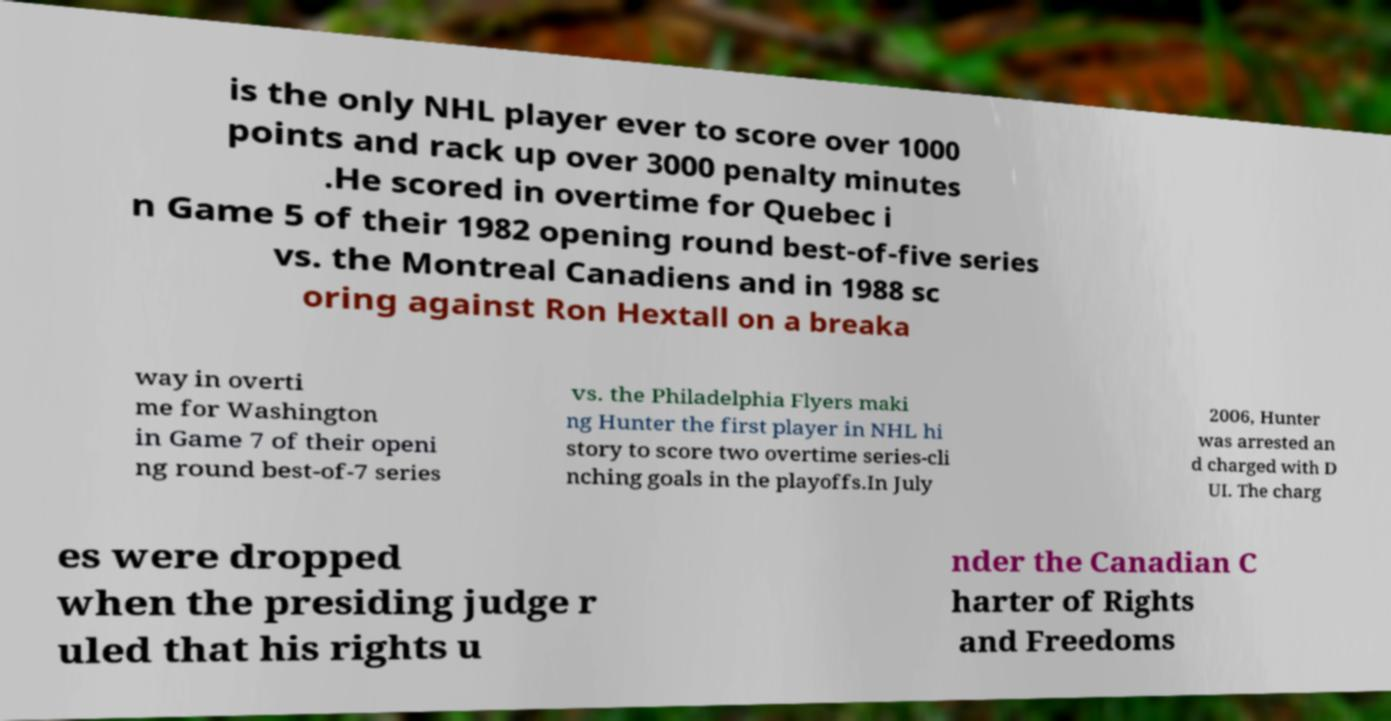Please read and relay the text visible in this image. What does it say? is the only NHL player ever to score over 1000 points and rack up over 3000 penalty minutes .He scored in overtime for Quebec i n Game 5 of their 1982 opening round best-of-five series vs. the Montreal Canadiens and in 1988 sc oring against Ron Hextall on a breaka way in overti me for Washington in Game 7 of their openi ng round best-of-7 series vs. the Philadelphia Flyers maki ng Hunter the first player in NHL hi story to score two overtime series-cli nching goals in the playoffs.In July 2006, Hunter was arrested an d charged with D UI. The charg es were dropped when the presiding judge r uled that his rights u nder the Canadian C harter of Rights and Freedoms 